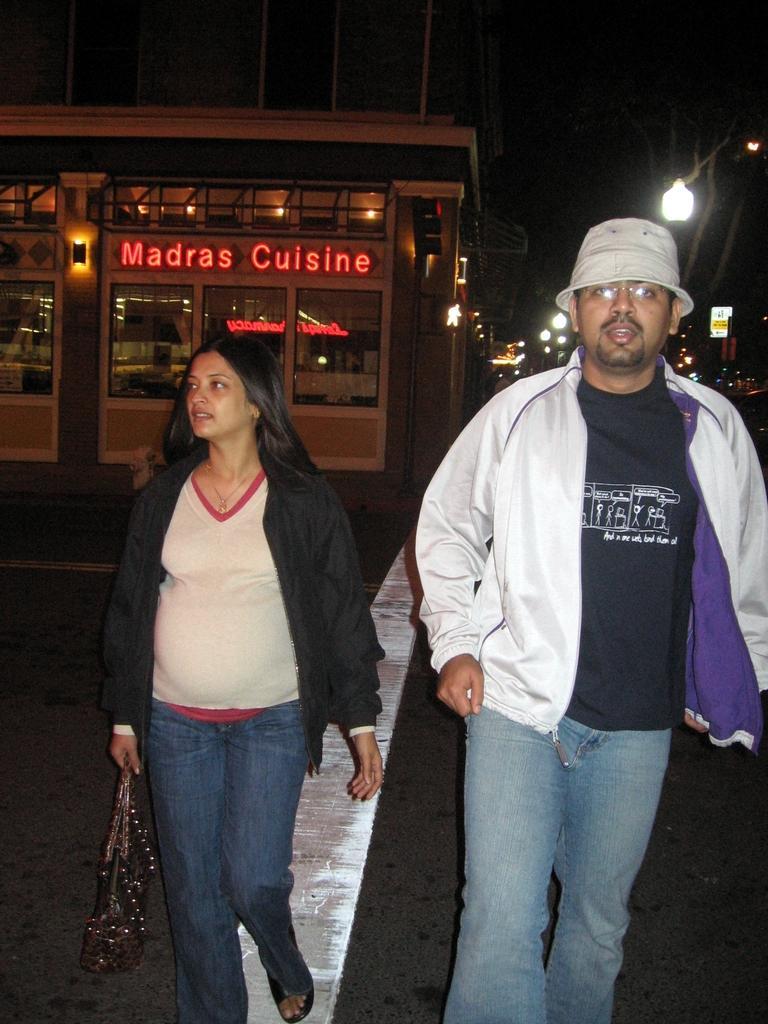Please provide a concise description of this image. There are two people walking and she is holding a bag. In the background we can see building and lights. 